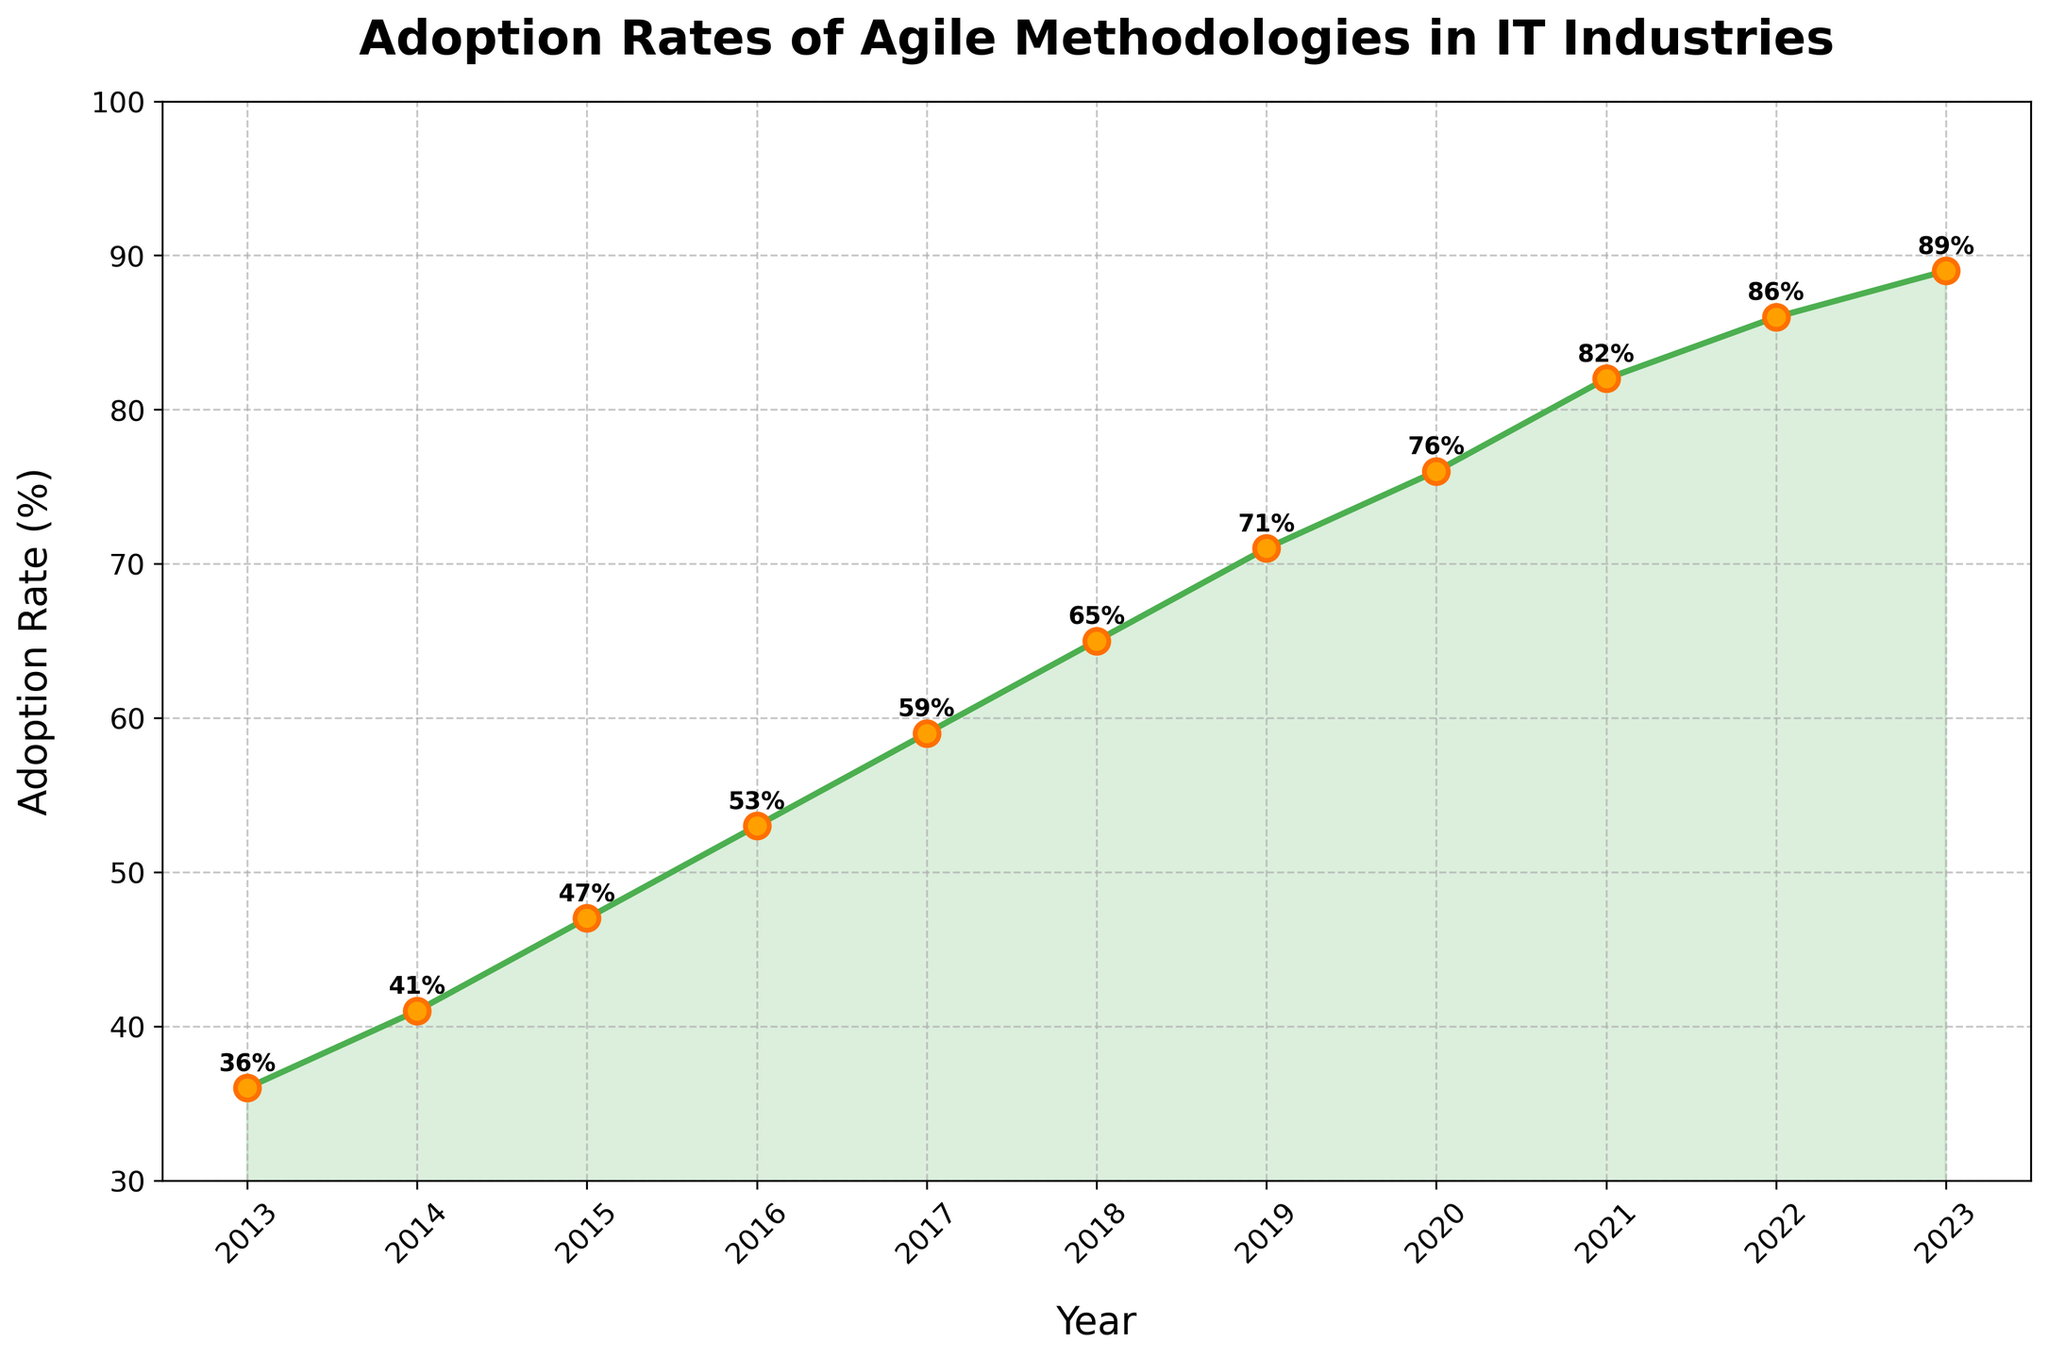What is the adoption rate of Agile methodologies in 2015? Look at the year 2015 on the x-axis and then trace up to the corresponding point on the line. The rate can be read as 47%.
Answer: 47% How much did the adoption rate increase from 2013 to 2017? Identify the adoption rates for 2013 which is 36% and for 2017 which is 59%. Calculate the difference: 59% - 36% = 23%.
Answer: 23% What year saw the biggest increase in adoption rate compared to the previous year? Examine the year-to-year adoption rates and find the largest difference. The increase from 2019 (71%) to 2020 (76%) is 5%, which is the largest.
Answer: 2020 Is there any year where the adoption rate did not increase from the previous year? Look for any points on the line where the adoption rate does not go up from the previous year. The line is consistently upward, indicating an increase every year.
Answer: No What is the average adoption rate over the decade shown? Sum all the adoption rates (36 + 41 + 47 + 53 + 59 + 65 + 71 + 76 + 82 + 86 + 89) which equals 705, then divide by the number of years (11): 705/11 ≈ 64.09%.
Answer: 64.09% Which year had an adoption rate of 76%? Find the point on the line that corresponds to 76% on the y-axis and trace down to the x-axis. The year is 2020.
Answer: 2020 How does the adoption rate in 2023 compare to that in 2013? Compare the adoption rates in 2023 (89%) and 2013 (36%). 2023 has a significantly higher adoption rate.
Answer: 2023 > 2013 What is the slope of the line between 2018 and 2020? The adoption rates for 2018 and 2020 are 65% and 76%, respectively, over 2 years. The slope is (76% - 65%) / (2020 - 2018) = 11% / 2 = 5.5% per year.
Answer: 5.5% per year Is the trend of adoption rates overall increasing, decreasing, or stable? The line from 2013 to 2023 shows an upward trajectory, indicating a consistent increase in adoption rates over the years.
Answer: Increasing What is the most frequent interval for y-axis ticks shown on the plot? Examine the y-axis and note the intervals between ticks. The ticks increase by 10% intervals (e.g., 30%, 40%, 50%, etc.).
Answer: 10% 